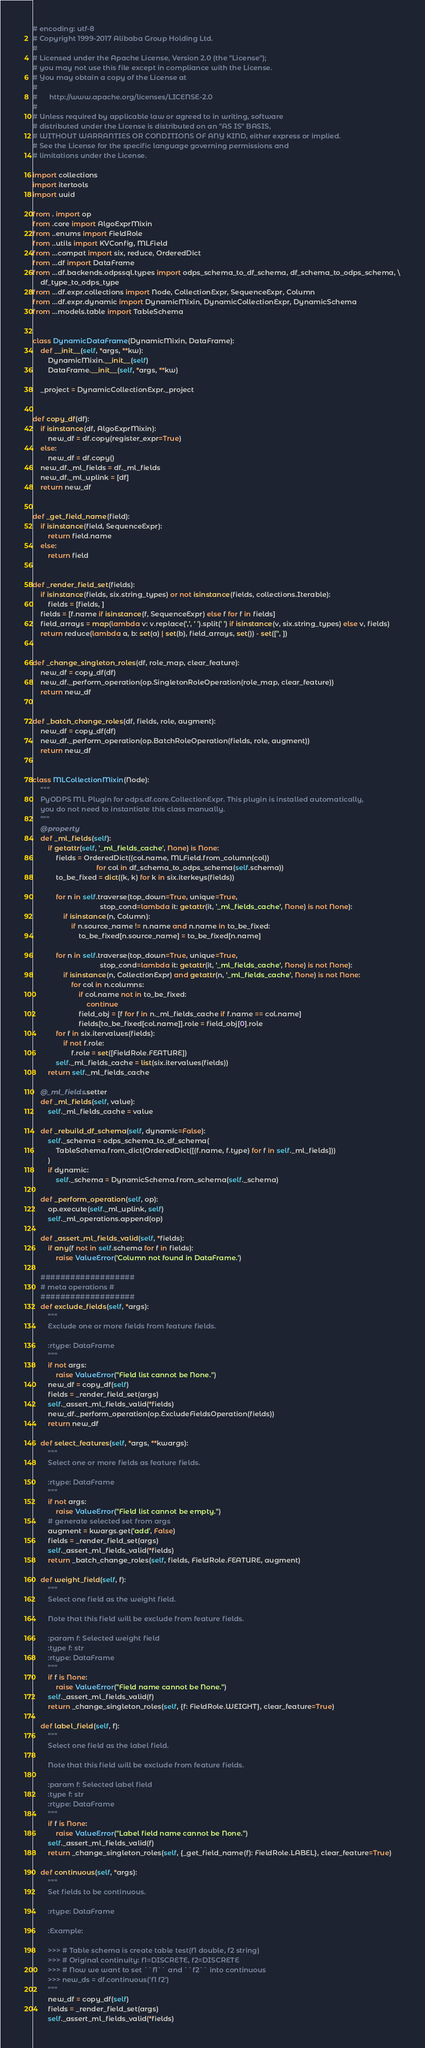<code> <loc_0><loc_0><loc_500><loc_500><_Python_># encoding: utf-8
# Copyright 1999-2017 Alibaba Group Holding Ltd.
# 
# Licensed under the Apache License, Version 2.0 (the "License");
# you may not use this file except in compliance with the License.
# You may obtain a copy of the License at
# 
#      http://www.apache.org/licenses/LICENSE-2.0
# 
# Unless required by applicable law or agreed to in writing, software
# distributed under the License is distributed on an "AS IS" BASIS,
# WITHOUT WARRANTIES OR CONDITIONS OF ANY KIND, either express or implied.
# See the License for the specific language governing permissions and
# limitations under the License.

import collections
import itertools
import uuid

from . import op
from .core import AlgoExprMixin
from ..enums import FieldRole
from ..utils import KVConfig, MLField
from ...compat import six, reduce, OrderedDict
from ...df import DataFrame
from ...df.backends.odpssql.types import odps_schema_to_df_schema, df_schema_to_odps_schema, \
    df_type_to_odps_type
from ...df.expr.collections import Node, CollectionExpr, SequenceExpr, Column
from ...df.expr.dynamic import DynamicMixin, DynamicCollectionExpr, DynamicSchema
from ...models.table import TableSchema


class DynamicDataFrame(DynamicMixin, DataFrame):
    def __init__(self, *args, **kw):
        DynamicMixin.__init__(self)
        DataFrame.__init__(self, *args, **kw)

    _project = DynamicCollectionExpr._project


def copy_df(df):
    if isinstance(df, AlgoExprMixin):
        new_df = df.copy(register_expr=True)
    else:
        new_df = df.copy()
    new_df._ml_fields = df._ml_fields
    new_df._ml_uplink = [df]
    return new_df


def _get_field_name(field):
    if isinstance(field, SequenceExpr):
        return field.name
    else:
        return field


def _render_field_set(fields):
    if isinstance(fields, six.string_types) or not isinstance(fields, collections.Iterable):
        fields = [fields, ]
    fields = [f.name if isinstance(f, SequenceExpr) else f for f in fields]
    field_arrays = map(lambda v: v.replace(',', ' ').split(' ') if isinstance(v, six.string_types) else v, fields)
    return reduce(lambda a, b: set(a) | set(b), field_arrays, set()) - set(['', ])


def _change_singleton_roles(df, role_map, clear_feature):
    new_df = copy_df(df)
    new_df._perform_operation(op.SingletonRoleOperation(role_map, clear_feature))
    return new_df


def _batch_change_roles(df, fields, role, augment):
    new_df = copy_df(df)
    new_df._perform_operation(op.BatchRoleOperation(fields, role, augment))
    return new_df


class MLCollectionMixin(Node):
    """
    PyODPS ML Plugin for odps.df.core.CollectionExpr. This plugin is installed automatically,
    you do not need to instantiate this class manually.
    """
    @property
    def _ml_fields(self):
        if getattr(self, '_ml_fields_cache', None) is None:
            fields = OrderedDict((col.name, MLField.from_column(col))
                                 for col in df_schema_to_odps_schema(self.schema))
            to_be_fixed = dict((k, k) for k in six.iterkeys(fields))

            for n in self.traverse(top_down=True, unique=True,
                                   stop_cond=lambda it: getattr(it, '_ml_fields_cache', None) is not None):
                if isinstance(n, Column):
                    if n.source_name != n.name and n.name in to_be_fixed:
                        to_be_fixed[n.source_name] = to_be_fixed[n.name]

            for n in self.traverse(top_down=True, unique=True,
                                   stop_cond=lambda it: getattr(it, '_ml_fields_cache', None) is not None):
                if isinstance(n, CollectionExpr) and getattr(n, '_ml_fields_cache', None) is not None:
                    for col in n.columns:
                        if col.name not in to_be_fixed:
                            continue
                        field_obj = [f for f in n._ml_fields_cache if f.name == col.name]
                        fields[to_be_fixed[col.name]].role = field_obj[0].role
            for f in six.itervalues(fields):
                if not f.role:
                    f.role = set([FieldRole.FEATURE])
            self._ml_fields_cache = list(six.itervalues(fields))
        return self._ml_fields_cache

    @_ml_fields.setter
    def _ml_fields(self, value):
        self._ml_fields_cache = value

    def _rebuild_df_schema(self, dynamic=False):
        self._schema = odps_schema_to_df_schema(
            TableSchema.from_dict(OrderedDict([(f.name, f.type) for f in self._ml_fields]))
        )
        if dynamic:
            self._schema = DynamicSchema.from_schema(self._schema)

    def _perform_operation(self, op):
        op.execute(self._ml_uplink, self)
        self._ml_operations.append(op)

    def _assert_ml_fields_valid(self, *fields):
        if any(f not in self.schema for f in fields):
            raise ValueError('Column not found in DataFrame.')

    ###################
    # meta operations #
    ###################
    def exclude_fields(self, *args):
        """
        Exclude one or more fields from feature fields.

        :rtype: DataFrame
        """
        if not args:
            raise ValueError("Field list cannot be None.")
        new_df = copy_df(self)
        fields = _render_field_set(args)
        self._assert_ml_fields_valid(*fields)
        new_df._perform_operation(op.ExcludeFieldsOperation(fields))
        return new_df

    def select_features(self, *args, **kwargs):
        """
        Select one or more fields as feature fields.

        :rtype: DataFrame
        """
        if not args:
            raise ValueError("Field list cannot be empty.")
        # generate selected set from args
        augment = kwargs.get('add', False)
        fields = _render_field_set(args)
        self._assert_ml_fields_valid(*fields)
        return _batch_change_roles(self, fields, FieldRole.FEATURE, augment)

    def weight_field(self, f):
        """
        Select one field as the weight field.

        Note that this field will be exclude from feature fields.

        :param f: Selected weight field
        :type f: str
        :rtype: DataFrame
        """
        if f is None:
            raise ValueError("Field name cannot be None.")
        self._assert_ml_fields_valid(f)
        return _change_singleton_roles(self, {f: FieldRole.WEIGHT}, clear_feature=True)

    def label_field(self, f):
        """
        Select one field as the label field.

        Note that this field will be exclude from feature fields.

        :param f: Selected label field
        :type f: str
        :rtype: DataFrame
        """
        if f is None:
            raise ValueError("Label field name cannot be None.")
        self._assert_ml_fields_valid(f)
        return _change_singleton_roles(self, {_get_field_name(f): FieldRole.LABEL}, clear_feature=True)

    def continuous(self, *args):
        """
        Set fields to be continuous.

        :rtype: DataFrame

        :Example:

        >>> # Table schema is create table test(f1 double, f2 string)
        >>> # Original continuity: f1=DISCRETE, f2=DISCRETE
        >>> # Now we want to set ``f1`` and ``f2`` into continuous
        >>> new_ds = df.continuous('f1 f2')
        """
        new_df = copy_df(self)
        fields = _render_field_set(args)
        self._assert_ml_fields_valid(*fields)</code> 